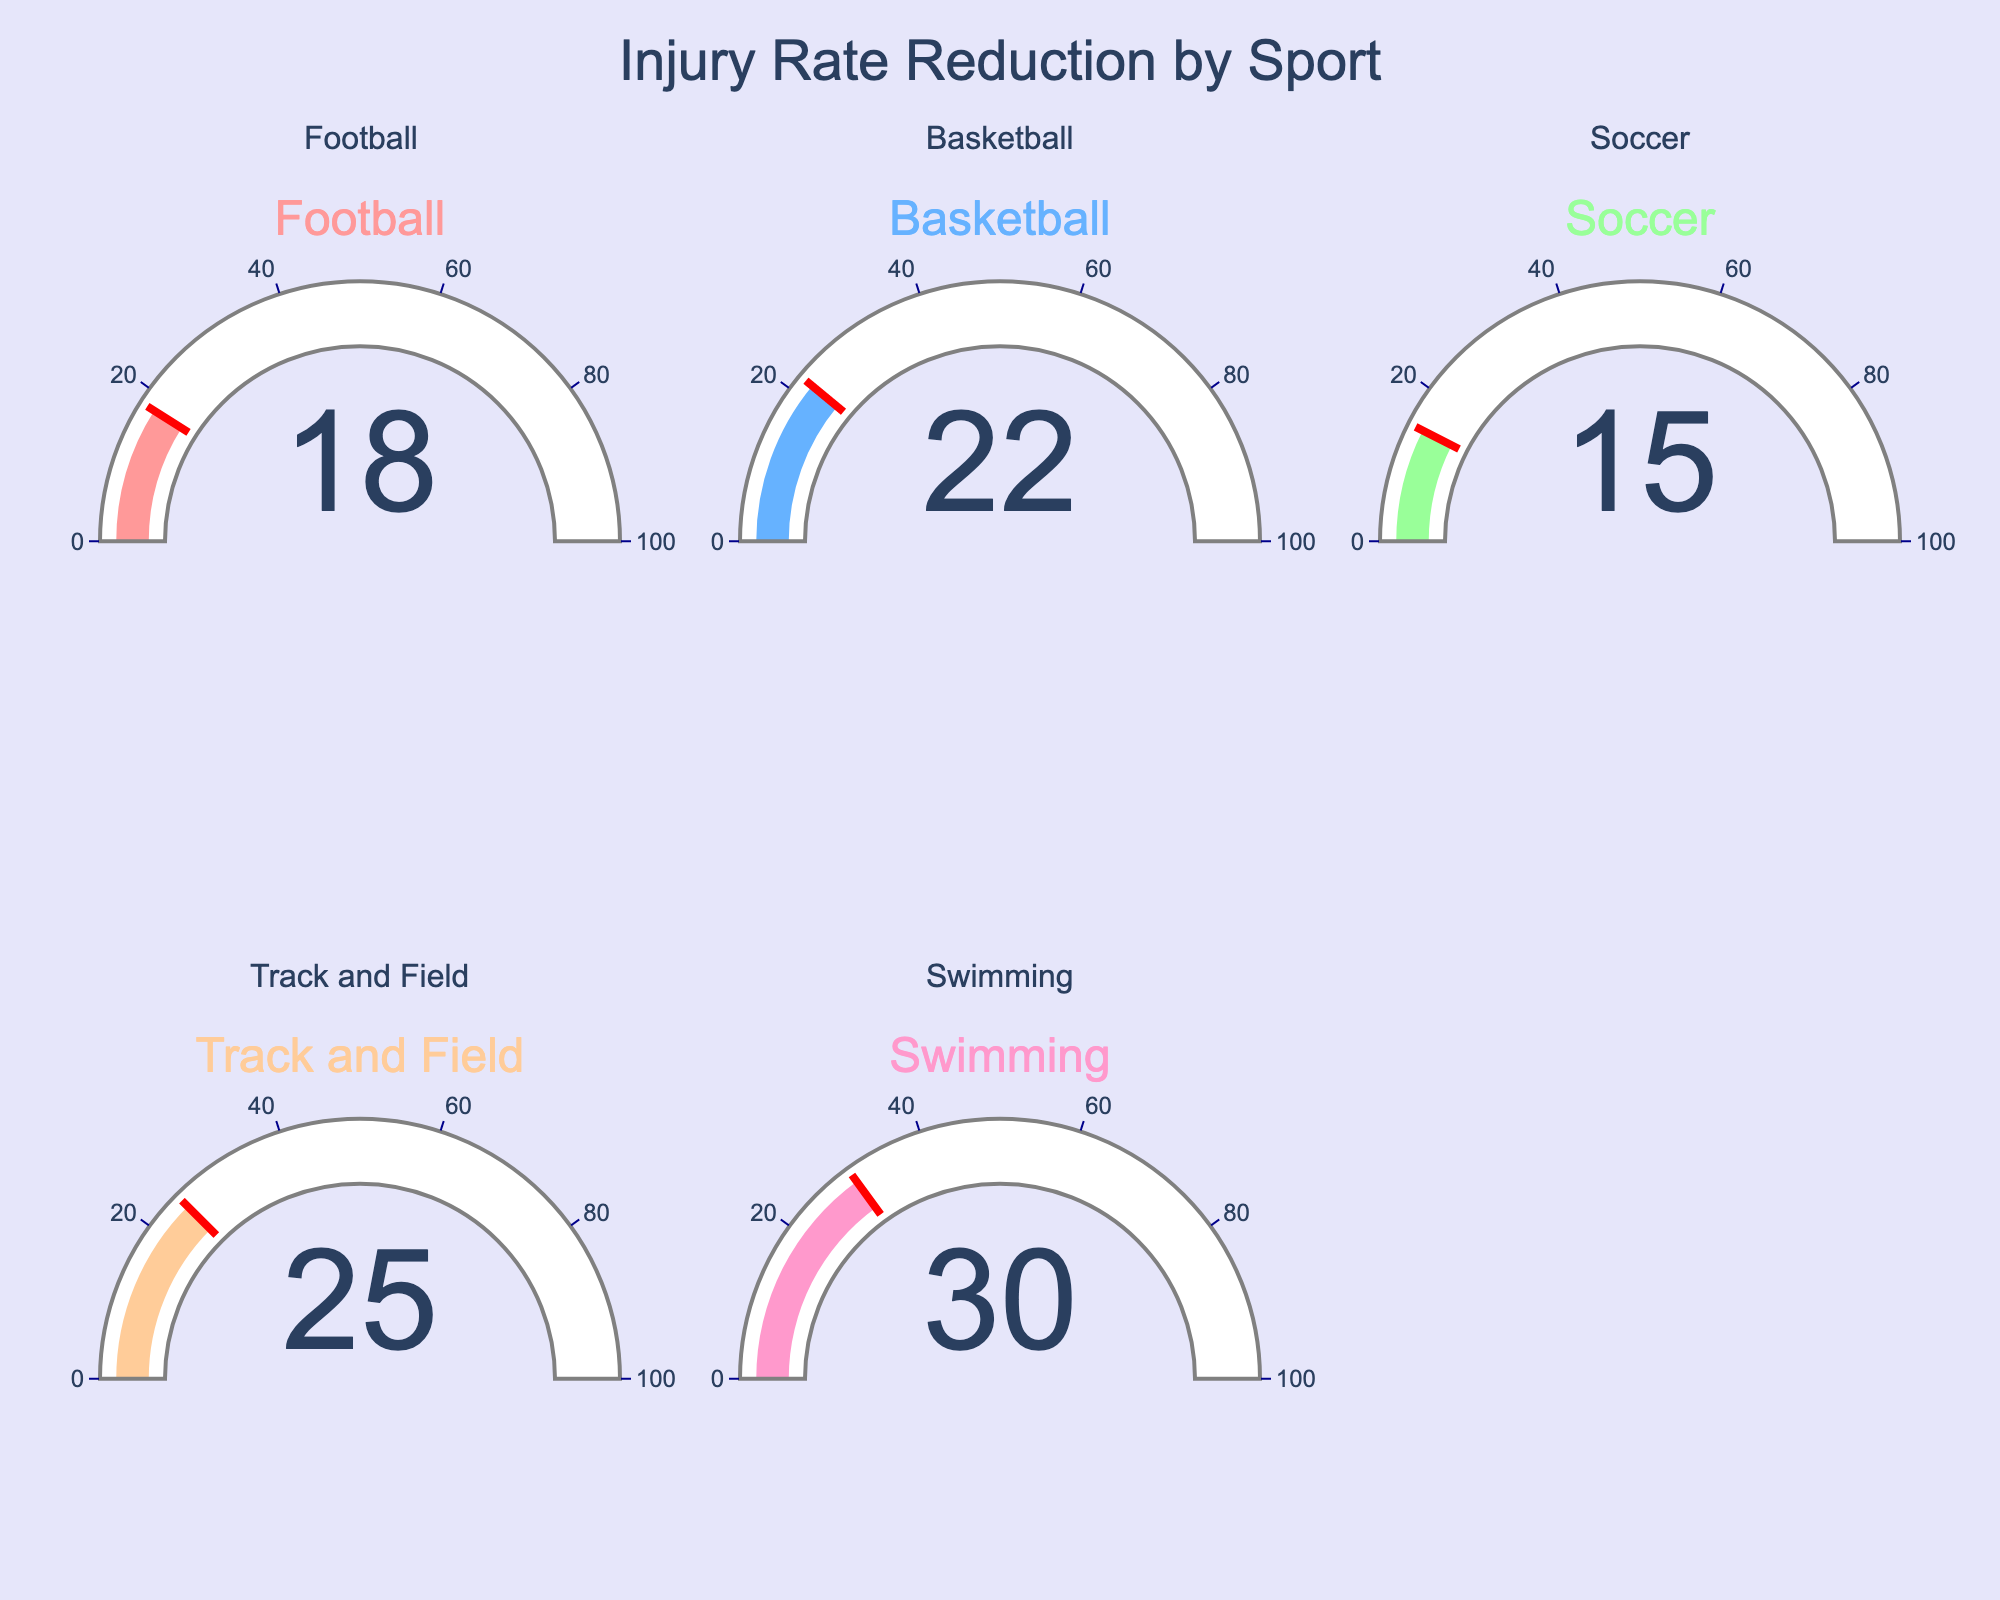What's the average injury rate reduction across all sports? To get the average, add the injury rate reductions for all sports: (18 + 22 + 15 + 25 + 30) = 110. Now, divide by the number of sports: 110 / 5 = 22
Answer: 22 Which sport has the highest injury rate reduction? Look at the gauge chart values and identify the highest number displayed. The highest injury rate reduction is 30 for Swimming.
Answer: Swimming Compare the injury rate reduction for Basketball and Soccer. Which is higher, and by how much? Basketball’s injury rate reduction is 22, and Soccer’s is 15. The difference is 22 - 15 = 7. So Basketball is higher by 7.
Answer: Basketball by 7 What's the cumulative injury rate reduction for Football and Track and Field? Add the injury rate reductions for Football and Track and Field: 18 + 25 = 43
Answer: 43 How much more is the injury rate reduction for Swimming compared to Football? Swimming’s injury rate reduction is 30, and Football’s is 18. The difference is 30 - 18 = 12
Answer: 12 What's the title of the gauge chart? The title of the gauge chart is "Injury Rate Reduction by Sport" as indicated at the top of the figure.
Answer: Injury Rate Reduction by Sport What color is associated with the gauge for Track and Field’s injury rate reduction? The gauge for Track and Field is colored in orange as per the custom color scale used in the figure.
Answer: Orange Are there any sports with an injury rate reduction below 20? Yes, the sports with an injury rate reduction below 20 are Football (18) and Soccer (15).
Answer: Football and Soccer What are the threshold markers shown on the gauges, and do any of them exceed the injury rate reduction values? The threshold markers are shown as red lines on each gauge. None of the markers exceed the actual injury rate reduction values as they are designed to be equal to these values.
Answer: No What is the difference in injury rate reduction between the sport with the highest reduction and the sport with the lowest reduction? The sport with the highest reduction is Swimming (30), and the sport with the lowest reduction is Soccer (15). The difference is 30 - 15 = 15.
Answer: 15 